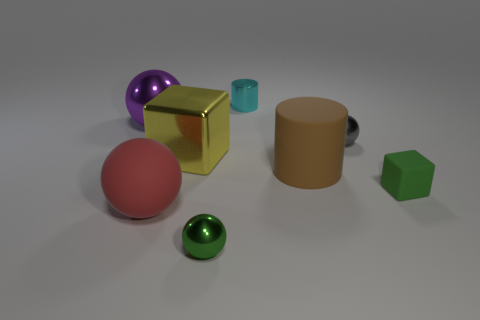Add 1 gray objects. How many objects exist? 9 Subtract all cubes. How many objects are left? 6 Subtract 0 gray blocks. How many objects are left? 8 Subtract all cyan metallic blocks. Subtract all cyan objects. How many objects are left? 7 Add 3 green rubber cubes. How many green rubber cubes are left? 4 Add 6 tiny cyan metal objects. How many tiny cyan metal objects exist? 7 